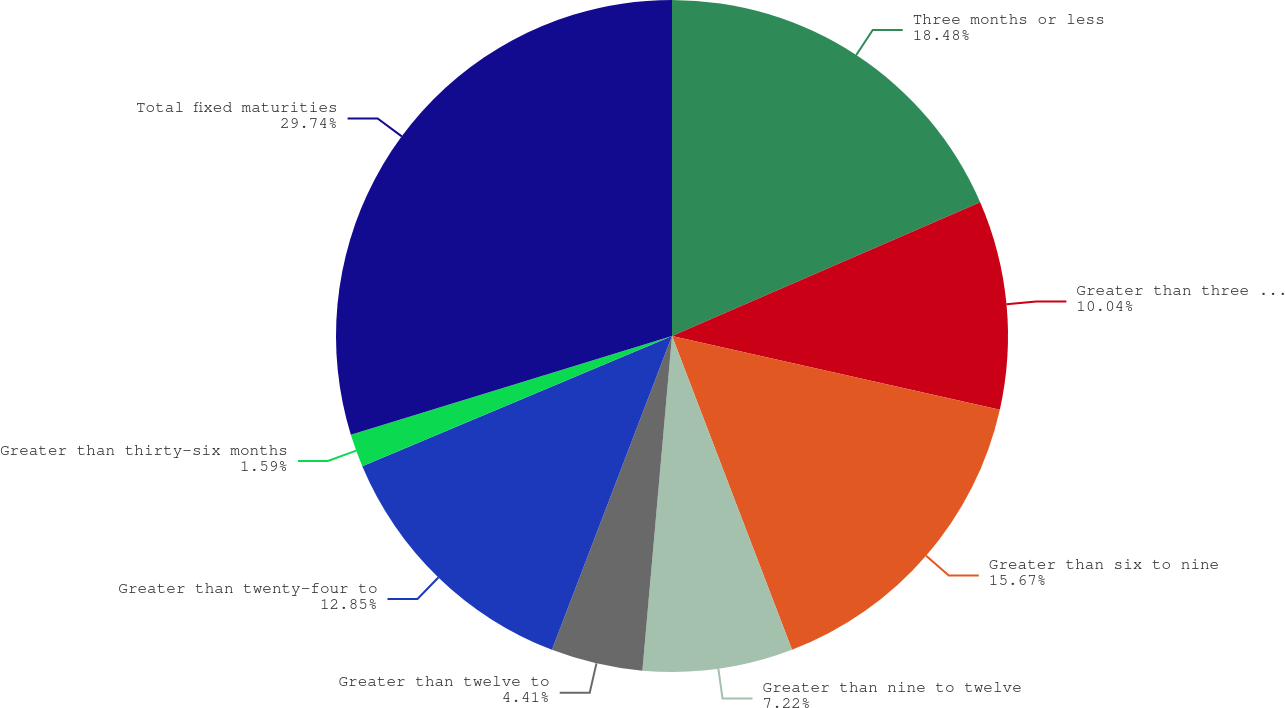<chart> <loc_0><loc_0><loc_500><loc_500><pie_chart><fcel>Three months or less<fcel>Greater than three to six<fcel>Greater than six to nine<fcel>Greater than nine to twelve<fcel>Greater than twelve to<fcel>Greater than twenty-four to<fcel>Greater than thirty-six months<fcel>Total fixed maturities<nl><fcel>18.48%<fcel>10.04%<fcel>15.67%<fcel>7.22%<fcel>4.41%<fcel>12.85%<fcel>1.59%<fcel>29.75%<nl></chart> 